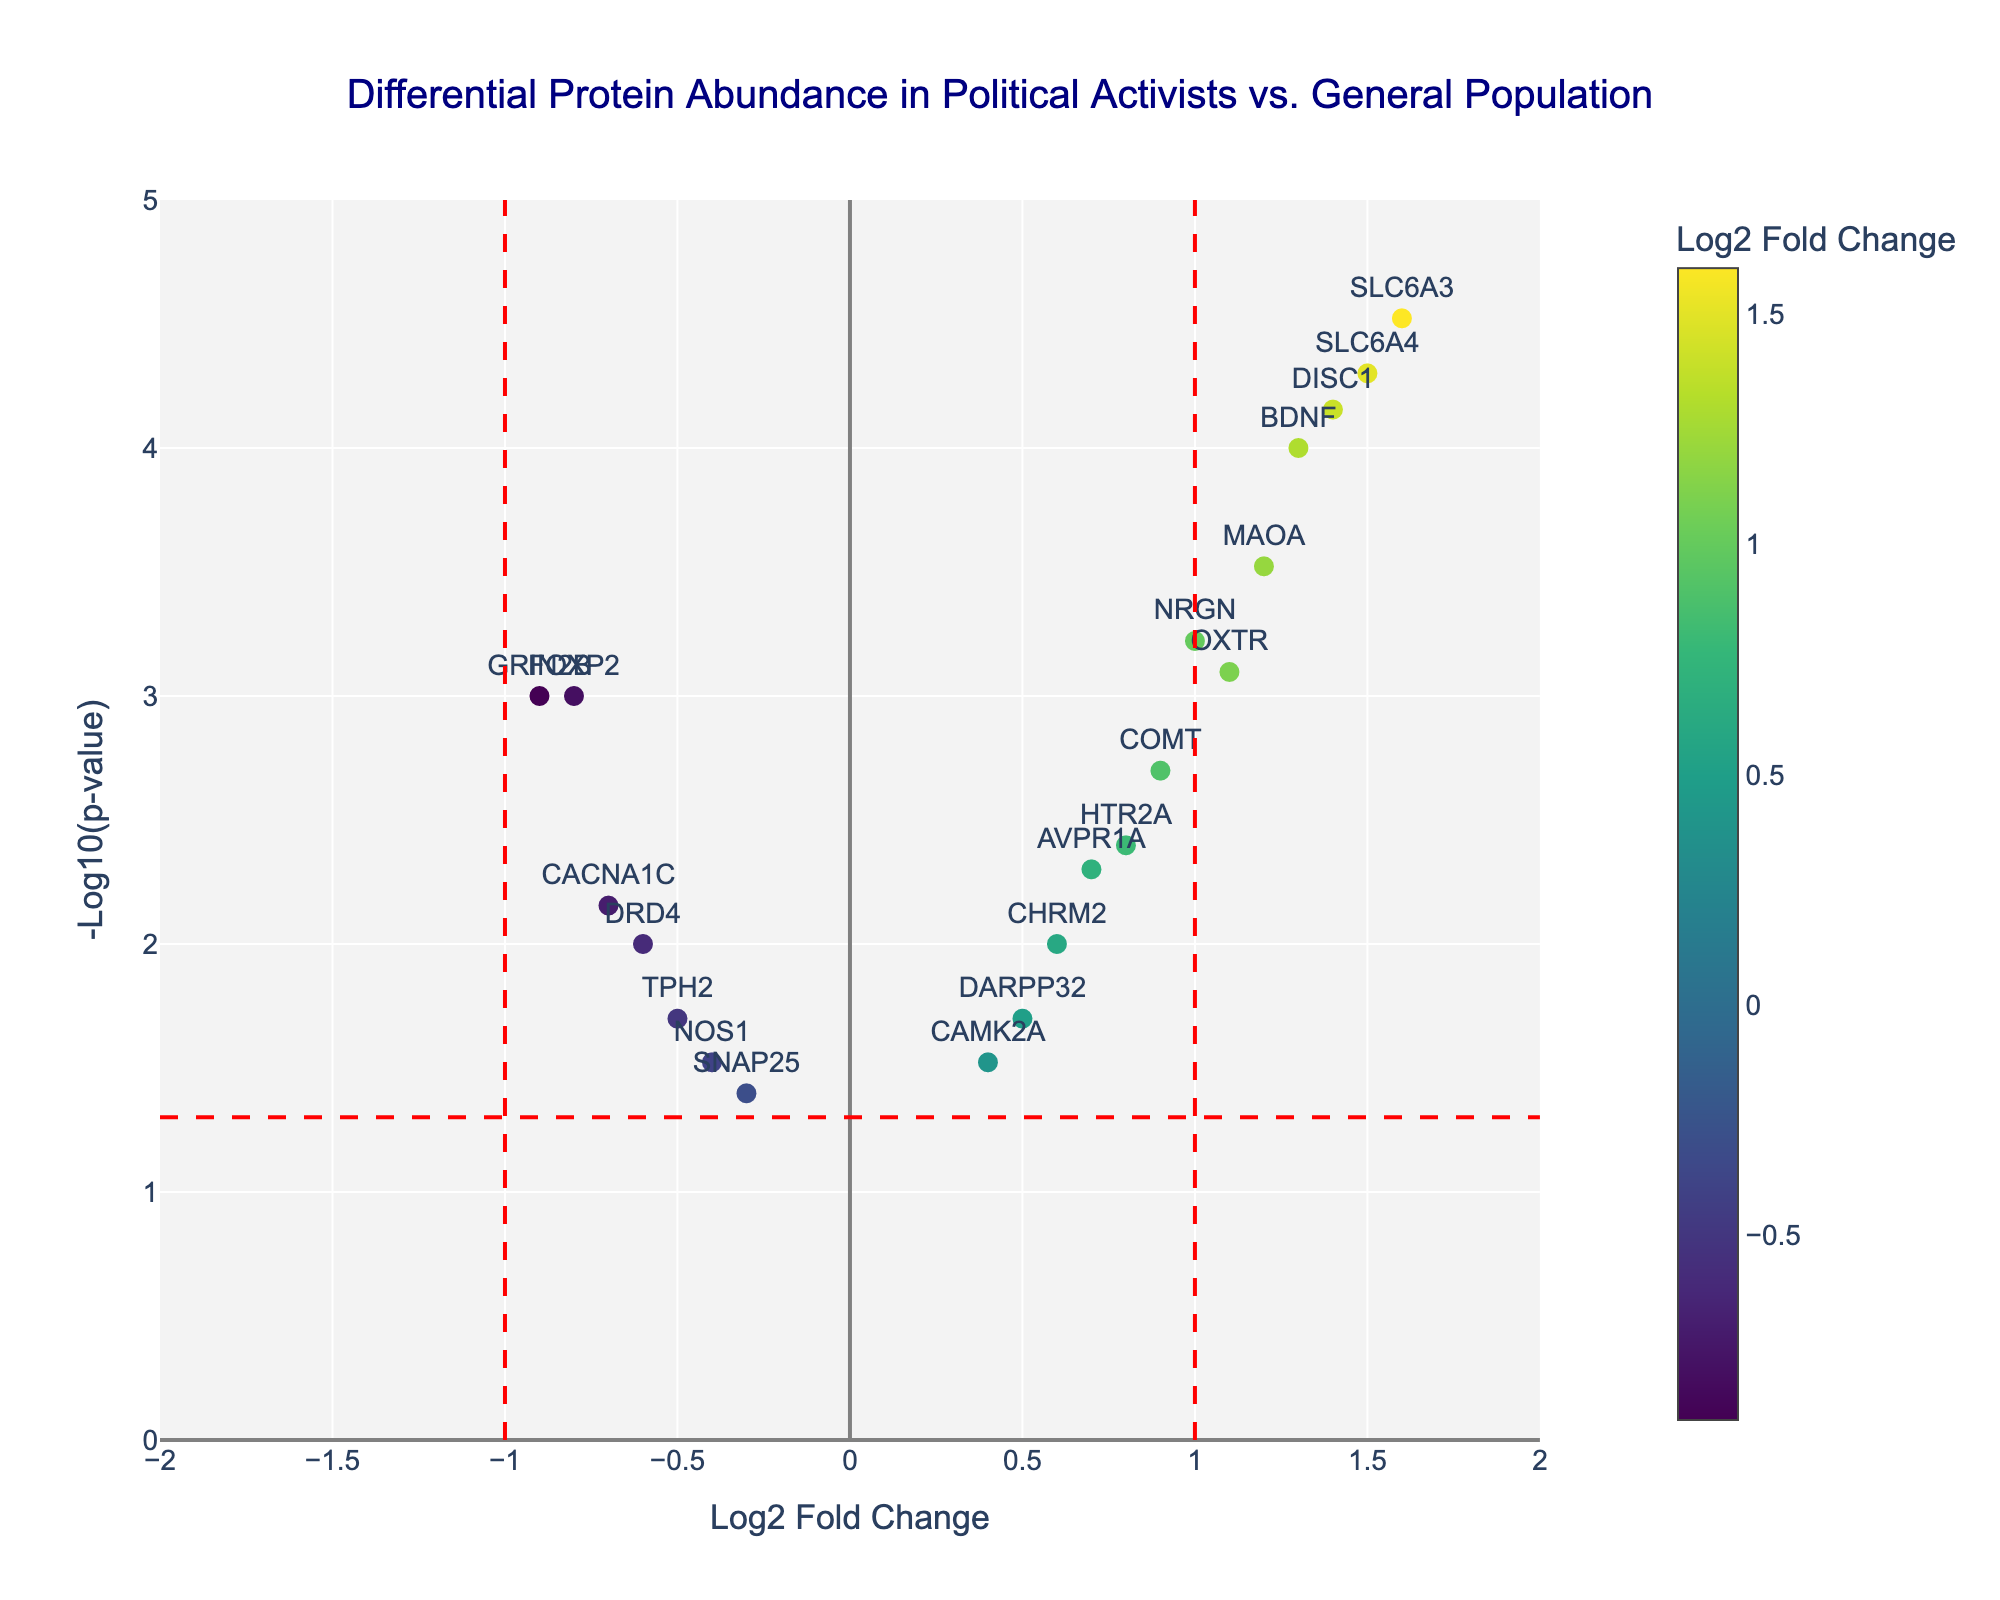What's the title of the plot? The title is located at the top of the plot and reads, "Differential Protein Abundance in Political Activists vs. General Population."
Answer: "Differential Protein Abundance in Political Activists vs. General Population" What do the axes represent? The x-axis represents "Log2 Fold Change", and the y-axis represents "-Log10(p-value)." These labels are shown beside each axis.
Answer: Log2 Fold Change (x), -Log10(p-value) (y) Which protein has the highest log2 fold change? By visually identifying the highest point on the x-axis, SLC6A3 has the highest log2 fold change of 1.6.
Answer: SLC6A3 How many proteins have a log2 fold change greater than 1 and -log10(p-value) greater than 3? Proteins with log2 fold change > 1 are on the right side of the vertical red line at x=1. Proteins with -log10(p-value) > 3 are above the horizontal red line at y=3. The proteins that meet both criteria are SLC6A4 and DISC1.
Answer: 2 (SLC6A4, DISC1) What protein has the lowest log2 fold change and what is its value? The lowest point on the x-axis corresponds to GRIN2B, which has a log2 fold change of -0.9.
Answer: GRIN2B (-0.9) Which proteins demonstrate a statistically significant change in abundance? Statistically significant changes are indicated by points above the red horizontal line at y = -log10(0.05). Proteins that meet this criterion are FOXP2, MAOA, COMT, SLC6A4, DRD4, OXTR, BDNF, NRGN, and DISC1, indicated by their location above the horizontal threshold.
Answer: FOXP2, MAOA, COMT, SLC6A4, DRD4, OXTR, BDNF, NRGN, DISC1 Which protein has the smallest p-value and what is its value? The smallest p-value corresponds to the highest point on the y-axis, which is SLC6A3 with a p-value of 0.00003.
Answer: SLC6A3 (0.00003) Is there a protein with a negative log2 fold change and a -log10(p-value) greater than 3? Yes, the plot shows GRIN2B with a log2 fold change of -0.9 and a -log10(p-value) just above 3.
Answer: GRIN2B How many proteins have a log2 fold change between -0.5 and 0.5? The log2 fold change range between -0.5 and 0.5 includes FOXP2, DRD4, AVPR1A, TPH2, NOS1, HTR2A, CACNA1C, DARPP32, and SNAP25. Count these proteins from the plot.
Answer: 9 